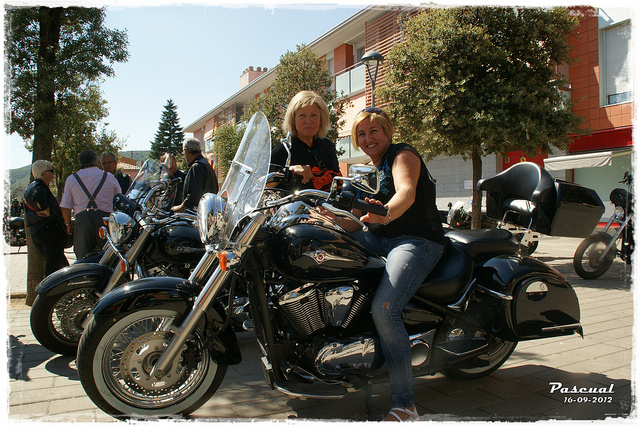Please transcribe the text in this image. PASUAL 16 09 -2012 